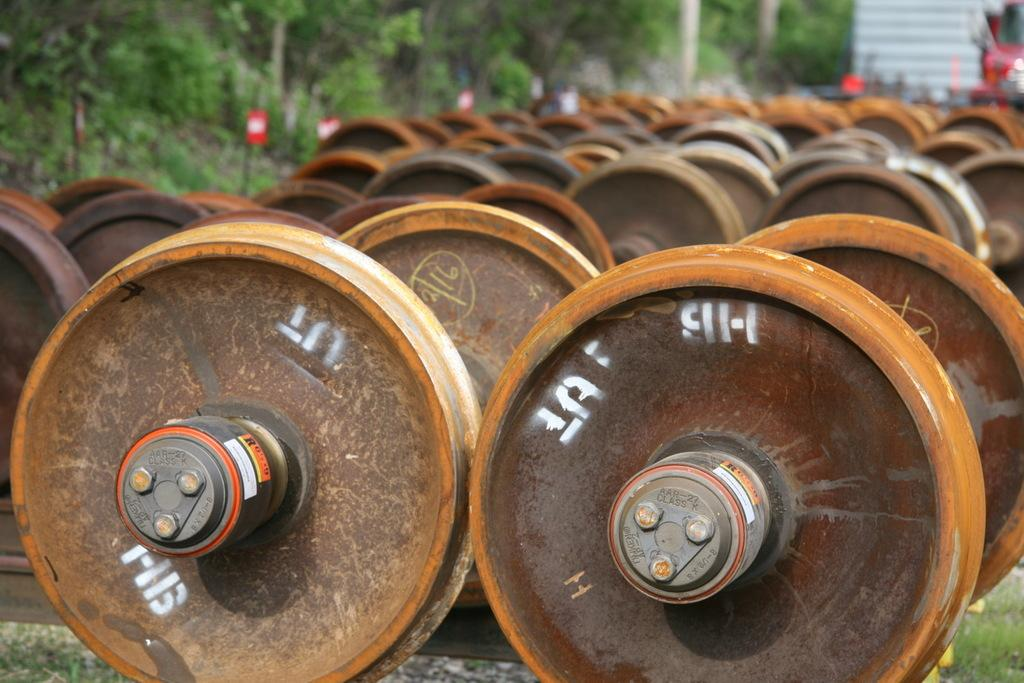What can be seen on the ground in the image? There are train wheels placed on the ground in the image. What type of natural environment is visible in the image? There are trees visible in the image. What type of crime is being committed in the image? There is no indication of any crime being committed in the image; it simply shows train wheels on the ground and trees in the background. 